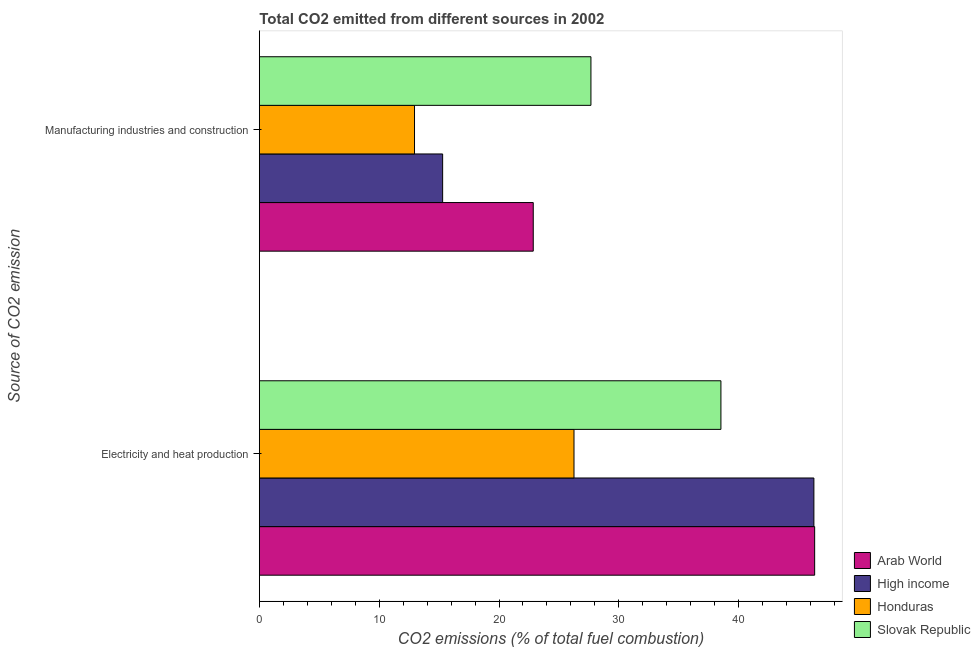How many groups of bars are there?
Provide a succinct answer. 2. Are the number of bars per tick equal to the number of legend labels?
Offer a terse response. Yes. What is the label of the 2nd group of bars from the top?
Your answer should be compact. Electricity and heat production. What is the co2 emissions due to manufacturing industries in Arab World?
Your response must be concise. 22.86. Across all countries, what is the maximum co2 emissions due to electricity and heat production?
Make the answer very short. 46.34. Across all countries, what is the minimum co2 emissions due to electricity and heat production?
Give a very brief answer. 26.26. In which country was the co2 emissions due to manufacturing industries maximum?
Make the answer very short. Slovak Republic. In which country was the co2 emissions due to manufacturing industries minimum?
Provide a short and direct response. Honduras. What is the total co2 emissions due to manufacturing industries in the graph?
Your answer should be very brief. 78.78. What is the difference between the co2 emissions due to manufacturing industries in Honduras and that in Slovak Republic?
Make the answer very short. -14.72. What is the difference between the co2 emissions due to manufacturing industries in Honduras and the co2 emissions due to electricity and heat production in High income?
Offer a terse response. -33.33. What is the average co2 emissions due to manufacturing industries per country?
Provide a succinct answer. 19.69. What is the difference between the co2 emissions due to manufacturing industries and co2 emissions due to electricity and heat production in High income?
Provide a succinct answer. -30.98. In how many countries, is the co2 emissions due to manufacturing industries greater than 26 %?
Provide a succinct answer. 1. What is the ratio of the co2 emissions due to manufacturing industries in High income to that in Slovak Republic?
Your answer should be very brief. 0.55. Is the co2 emissions due to electricity and heat production in Honduras less than that in High income?
Offer a terse response. Yes. In how many countries, is the co2 emissions due to electricity and heat production greater than the average co2 emissions due to electricity and heat production taken over all countries?
Your answer should be compact. 2. What does the 4th bar from the top in Manufacturing industries and construction represents?
Make the answer very short. Arab World. What does the 4th bar from the bottom in Manufacturing industries and construction represents?
Offer a very short reply. Slovak Republic. How many bars are there?
Give a very brief answer. 8. Are all the bars in the graph horizontal?
Ensure brevity in your answer.  Yes. What is the difference between two consecutive major ticks on the X-axis?
Give a very brief answer. 10. Are the values on the major ticks of X-axis written in scientific E-notation?
Your answer should be very brief. No. Does the graph contain any zero values?
Your response must be concise. No. Does the graph contain grids?
Give a very brief answer. No. Where does the legend appear in the graph?
Provide a succinct answer. Bottom right. What is the title of the graph?
Make the answer very short. Total CO2 emitted from different sources in 2002. What is the label or title of the X-axis?
Give a very brief answer. CO2 emissions (% of total fuel combustion). What is the label or title of the Y-axis?
Your answer should be very brief. Source of CO2 emission. What is the CO2 emissions (% of total fuel combustion) of Arab World in Electricity and heat production?
Keep it short and to the point. 46.34. What is the CO2 emissions (% of total fuel combustion) in High income in Electricity and heat production?
Provide a short and direct response. 46.28. What is the CO2 emissions (% of total fuel combustion) of Honduras in Electricity and heat production?
Your answer should be compact. 26.26. What is the CO2 emissions (% of total fuel combustion) of Slovak Republic in Electricity and heat production?
Offer a very short reply. 38.52. What is the CO2 emissions (% of total fuel combustion) of Arab World in Manufacturing industries and construction?
Offer a terse response. 22.86. What is the CO2 emissions (% of total fuel combustion) of High income in Manufacturing industries and construction?
Ensure brevity in your answer.  15.3. What is the CO2 emissions (% of total fuel combustion) in Honduras in Manufacturing industries and construction?
Provide a succinct answer. 12.95. What is the CO2 emissions (% of total fuel combustion) of Slovak Republic in Manufacturing industries and construction?
Give a very brief answer. 27.67. Across all Source of CO2 emission, what is the maximum CO2 emissions (% of total fuel combustion) in Arab World?
Make the answer very short. 46.34. Across all Source of CO2 emission, what is the maximum CO2 emissions (% of total fuel combustion) of High income?
Offer a terse response. 46.28. Across all Source of CO2 emission, what is the maximum CO2 emissions (% of total fuel combustion) in Honduras?
Ensure brevity in your answer.  26.26. Across all Source of CO2 emission, what is the maximum CO2 emissions (% of total fuel combustion) in Slovak Republic?
Keep it short and to the point. 38.52. Across all Source of CO2 emission, what is the minimum CO2 emissions (% of total fuel combustion) in Arab World?
Your answer should be compact. 22.86. Across all Source of CO2 emission, what is the minimum CO2 emissions (% of total fuel combustion) in High income?
Provide a short and direct response. 15.3. Across all Source of CO2 emission, what is the minimum CO2 emissions (% of total fuel combustion) of Honduras?
Make the answer very short. 12.95. Across all Source of CO2 emission, what is the minimum CO2 emissions (% of total fuel combustion) of Slovak Republic?
Give a very brief answer. 27.67. What is the total CO2 emissions (% of total fuel combustion) of Arab World in the graph?
Offer a very short reply. 69.2. What is the total CO2 emissions (% of total fuel combustion) of High income in the graph?
Your answer should be very brief. 61.58. What is the total CO2 emissions (% of total fuel combustion) of Honduras in the graph?
Your response must be concise. 39.21. What is the total CO2 emissions (% of total fuel combustion) in Slovak Republic in the graph?
Offer a terse response. 66.19. What is the difference between the CO2 emissions (% of total fuel combustion) of Arab World in Electricity and heat production and that in Manufacturing industries and construction?
Your answer should be very brief. 23.48. What is the difference between the CO2 emissions (% of total fuel combustion) in High income in Electricity and heat production and that in Manufacturing industries and construction?
Your answer should be compact. 30.98. What is the difference between the CO2 emissions (% of total fuel combustion) in Honduras in Electricity and heat production and that in Manufacturing industries and construction?
Ensure brevity in your answer.  13.31. What is the difference between the CO2 emissions (% of total fuel combustion) in Slovak Republic in Electricity and heat production and that in Manufacturing industries and construction?
Ensure brevity in your answer.  10.85. What is the difference between the CO2 emissions (% of total fuel combustion) in Arab World in Electricity and heat production and the CO2 emissions (% of total fuel combustion) in High income in Manufacturing industries and construction?
Provide a short and direct response. 31.04. What is the difference between the CO2 emissions (% of total fuel combustion) in Arab World in Electricity and heat production and the CO2 emissions (% of total fuel combustion) in Honduras in Manufacturing industries and construction?
Your answer should be very brief. 33.39. What is the difference between the CO2 emissions (% of total fuel combustion) in Arab World in Electricity and heat production and the CO2 emissions (% of total fuel combustion) in Slovak Republic in Manufacturing industries and construction?
Offer a very short reply. 18.67. What is the difference between the CO2 emissions (% of total fuel combustion) of High income in Electricity and heat production and the CO2 emissions (% of total fuel combustion) of Honduras in Manufacturing industries and construction?
Make the answer very short. 33.33. What is the difference between the CO2 emissions (% of total fuel combustion) in High income in Electricity and heat production and the CO2 emissions (% of total fuel combustion) in Slovak Republic in Manufacturing industries and construction?
Your answer should be compact. 18.61. What is the difference between the CO2 emissions (% of total fuel combustion) of Honduras in Electricity and heat production and the CO2 emissions (% of total fuel combustion) of Slovak Republic in Manufacturing industries and construction?
Offer a terse response. -1.41. What is the average CO2 emissions (% of total fuel combustion) in Arab World per Source of CO2 emission?
Provide a short and direct response. 34.6. What is the average CO2 emissions (% of total fuel combustion) of High income per Source of CO2 emission?
Give a very brief answer. 30.79. What is the average CO2 emissions (% of total fuel combustion) of Honduras per Source of CO2 emission?
Provide a short and direct response. 19.6. What is the average CO2 emissions (% of total fuel combustion) in Slovak Republic per Source of CO2 emission?
Your answer should be very brief. 33.1. What is the difference between the CO2 emissions (% of total fuel combustion) of Arab World and CO2 emissions (% of total fuel combustion) of High income in Electricity and heat production?
Provide a succinct answer. 0.06. What is the difference between the CO2 emissions (% of total fuel combustion) of Arab World and CO2 emissions (% of total fuel combustion) of Honduras in Electricity and heat production?
Your response must be concise. 20.08. What is the difference between the CO2 emissions (% of total fuel combustion) of Arab World and CO2 emissions (% of total fuel combustion) of Slovak Republic in Electricity and heat production?
Provide a succinct answer. 7.82. What is the difference between the CO2 emissions (% of total fuel combustion) in High income and CO2 emissions (% of total fuel combustion) in Honduras in Electricity and heat production?
Provide a short and direct response. 20.02. What is the difference between the CO2 emissions (% of total fuel combustion) in High income and CO2 emissions (% of total fuel combustion) in Slovak Republic in Electricity and heat production?
Ensure brevity in your answer.  7.76. What is the difference between the CO2 emissions (% of total fuel combustion) of Honduras and CO2 emissions (% of total fuel combustion) of Slovak Republic in Electricity and heat production?
Provide a short and direct response. -12.26. What is the difference between the CO2 emissions (% of total fuel combustion) of Arab World and CO2 emissions (% of total fuel combustion) of High income in Manufacturing industries and construction?
Offer a very short reply. 7.56. What is the difference between the CO2 emissions (% of total fuel combustion) of Arab World and CO2 emissions (% of total fuel combustion) of Honduras in Manufacturing industries and construction?
Provide a succinct answer. 9.91. What is the difference between the CO2 emissions (% of total fuel combustion) of Arab World and CO2 emissions (% of total fuel combustion) of Slovak Republic in Manufacturing industries and construction?
Keep it short and to the point. -4.81. What is the difference between the CO2 emissions (% of total fuel combustion) of High income and CO2 emissions (% of total fuel combustion) of Honduras in Manufacturing industries and construction?
Ensure brevity in your answer.  2.35. What is the difference between the CO2 emissions (% of total fuel combustion) of High income and CO2 emissions (% of total fuel combustion) of Slovak Republic in Manufacturing industries and construction?
Offer a terse response. -12.38. What is the difference between the CO2 emissions (% of total fuel combustion) in Honduras and CO2 emissions (% of total fuel combustion) in Slovak Republic in Manufacturing industries and construction?
Provide a succinct answer. -14.72. What is the ratio of the CO2 emissions (% of total fuel combustion) in Arab World in Electricity and heat production to that in Manufacturing industries and construction?
Keep it short and to the point. 2.03. What is the ratio of the CO2 emissions (% of total fuel combustion) in High income in Electricity and heat production to that in Manufacturing industries and construction?
Keep it short and to the point. 3.03. What is the ratio of the CO2 emissions (% of total fuel combustion) in Honduras in Electricity and heat production to that in Manufacturing industries and construction?
Your answer should be compact. 2.03. What is the ratio of the CO2 emissions (% of total fuel combustion) in Slovak Republic in Electricity and heat production to that in Manufacturing industries and construction?
Your answer should be compact. 1.39. What is the difference between the highest and the second highest CO2 emissions (% of total fuel combustion) of Arab World?
Your answer should be compact. 23.48. What is the difference between the highest and the second highest CO2 emissions (% of total fuel combustion) of High income?
Provide a short and direct response. 30.98. What is the difference between the highest and the second highest CO2 emissions (% of total fuel combustion) in Honduras?
Ensure brevity in your answer.  13.31. What is the difference between the highest and the second highest CO2 emissions (% of total fuel combustion) of Slovak Republic?
Provide a short and direct response. 10.85. What is the difference between the highest and the lowest CO2 emissions (% of total fuel combustion) in Arab World?
Offer a terse response. 23.48. What is the difference between the highest and the lowest CO2 emissions (% of total fuel combustion) in High income?
Make the answer very short. 30.98. What is the difference between the highest and the lowest CO2 emissions (% of total fuel combustion) in Honduras?
Provide a succinct answer. 13.31. What is the difference between the highest and the lowest CO2 emissions (% of total fuel combustion) in Slovak Republic?
Offer a terse response. 10.85. 